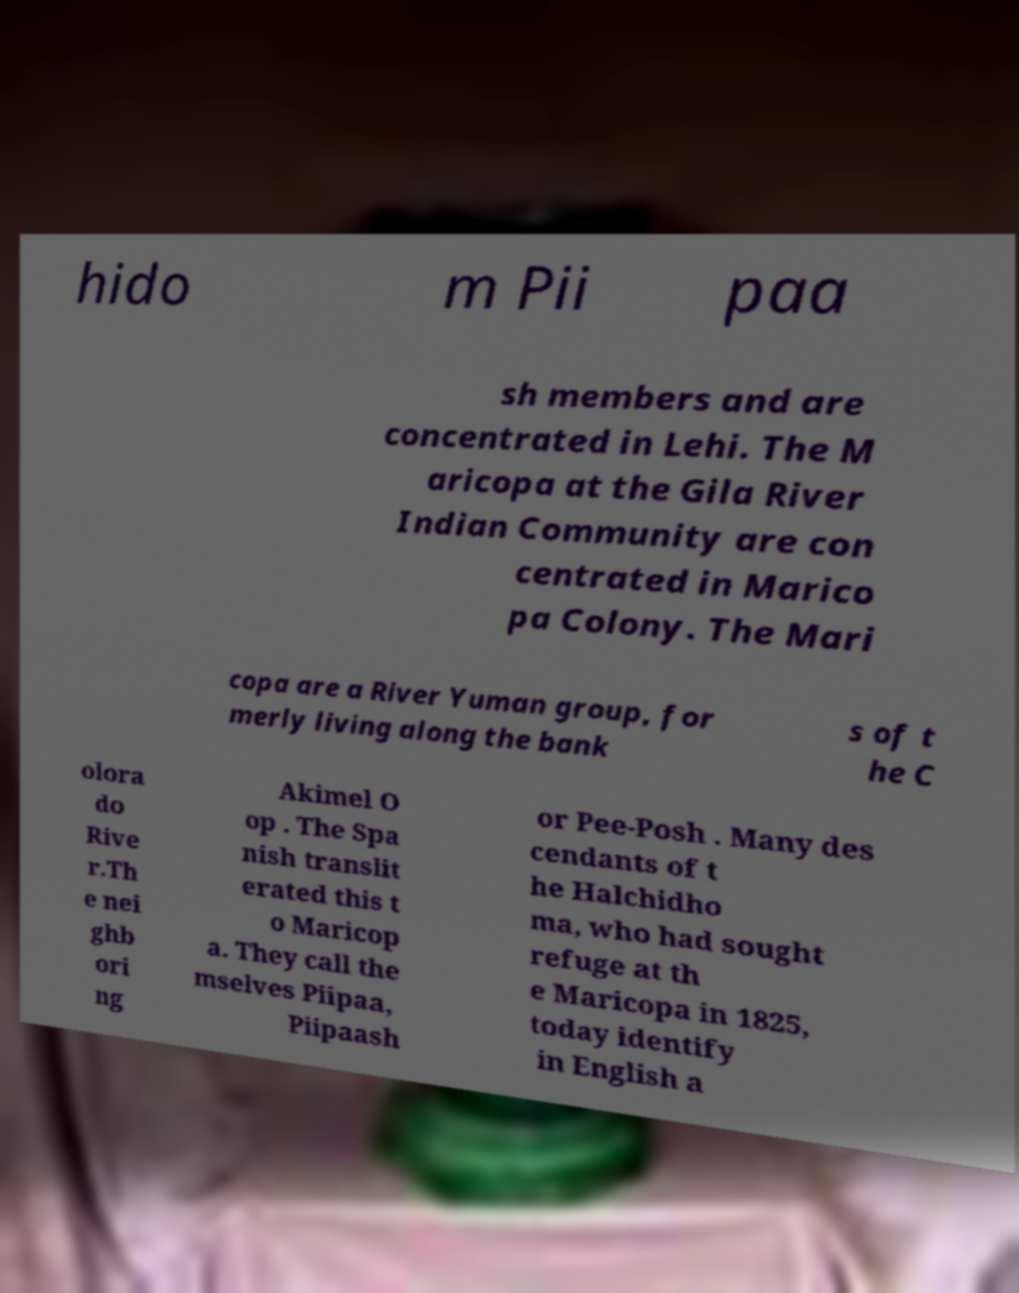Can you accurately transcribe the text from the provided image for me? hido m Pii paa sh members and are concentrated in Lehi. The M aricopa at the Gila River Indian Community are con centrated in Marico pa Colony. The Mari copa are a River Yuman group, for merly living along the bank s of t he C olora do Rive r.Th e nei ghb ori ng Akimel O op . The Spa nish translit erated this t o Maricop a. They call the mselves Piipaa, Piipaash or Pee-Posh . Many des cendants of t he Halchidho ma, who had sought refuge at th e Maricopa in 1825, today identify in English a 